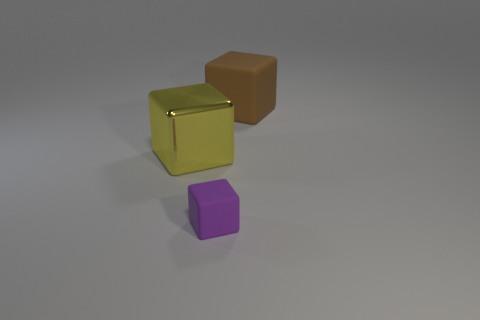Can you describe the shapes and their arrangement in the image? In the image, there are three geometric shapes: a large golden cube, a smaller purple cube, and a medium-sized brown cube. They are arranged in a staggered line with the purple cube upfront, slightly to the right of center, the golden cube to its left, and the brown cube towards the back on the right. 